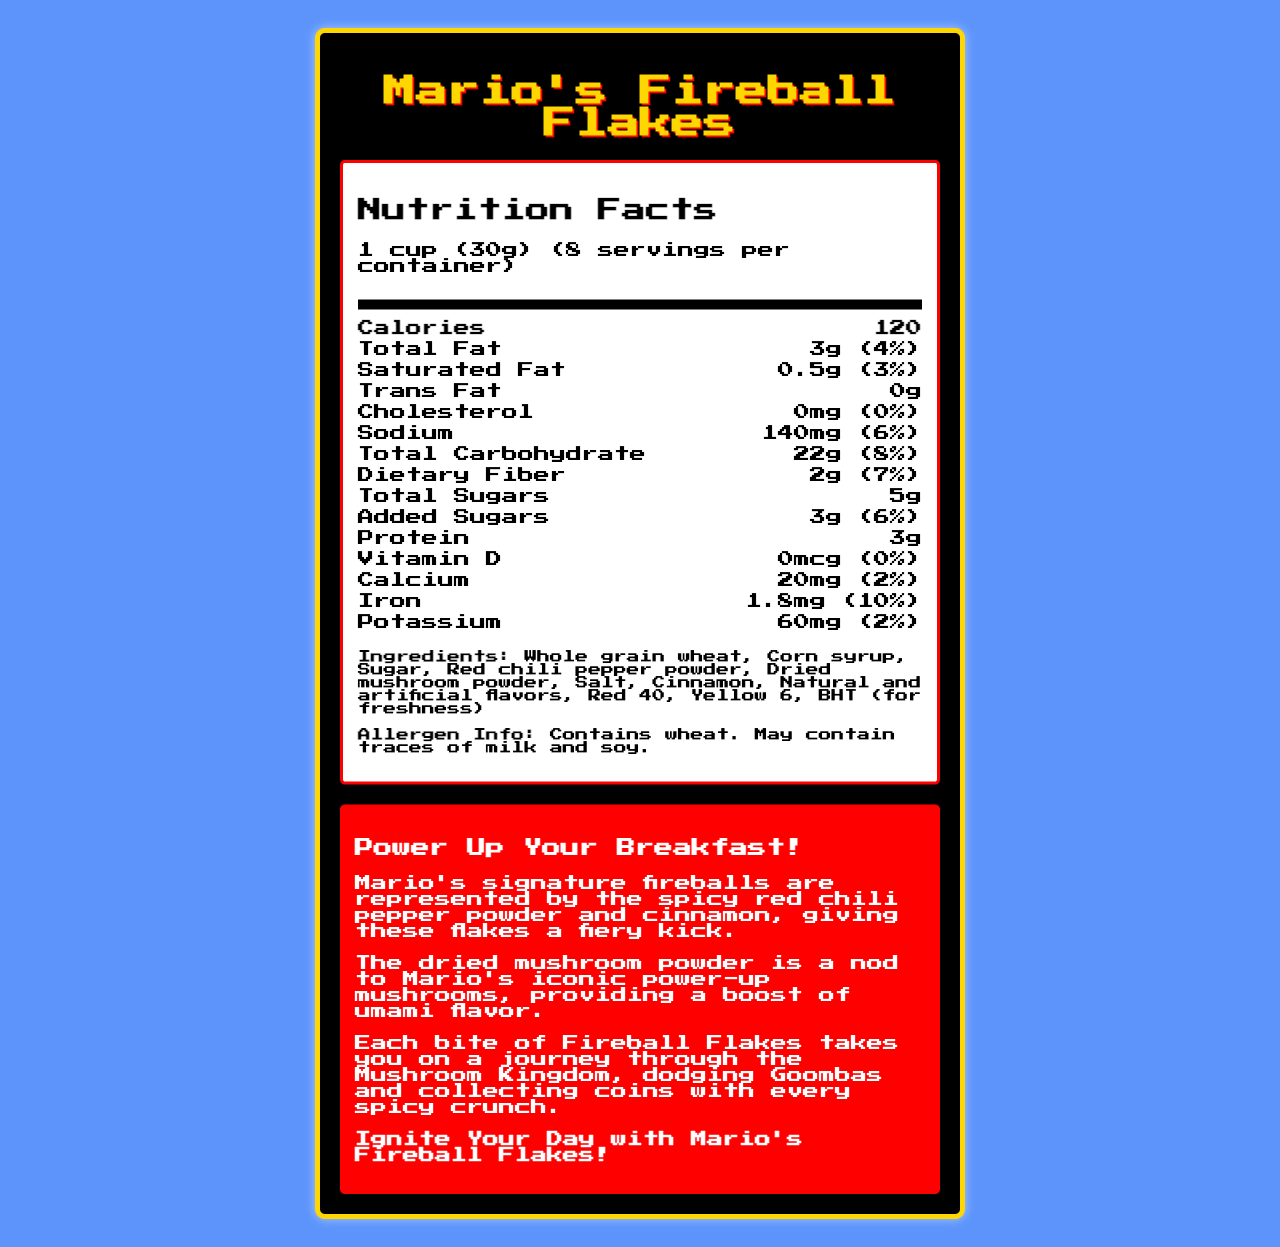what is the serving size for Mario's Fireball Flakes? The serving size is listed at the top of the Nutrition Facts section.
Answer: 1 cup (30g) How many calories are in one serving? The number of calories per serving is indicated in the Nutrition Facts section next to "Calories".
Answer: 120 What unique ingredient ties into Mario's fireball ability? The character tie-in narrative mentions red chili pepper powder representing Mario's fireballs.
Answer: Red chili pepper powder How many grams of protein are in one serving? The protein amount is listed in the Nutrition Facts section.
Answer: 3g What is the daily percentage value of potassium in one serving? The percent daily value for potassium is outlined in the Nutrition Facts section.
Answer: 2% What colors are used to match Mario's classic outfit in the cereal? A. Red and Blue B. Red and Yellow C. Yellow and Green D. Green and Blue The color scheme is mentioned as vibrant red and yellow to match Mario's classic outfit.
Answer: B. Red and Yellow Which power-up reference is related to the dried mushroom powder? 1. Fireballs 2. Super Star 3. Power-up mushrooms The dried mushroom powder is a nod to Mario's power-up mushrooms as per the narrative.
Answer: 3. Power-up mushrooms Does Mario's Fireball Flakes contain any traces of soy? The allergen info states that it may contain traces of milk and soy.
Answer: Yes What is the main idea of the document? The document provides a comprehensive overview of both the nutritional content and the thematic narrative related to the cereal.
Answer: The document is a Nutrition Facts label for a themed snack cereal called "Mario's Fireball Flakes," which integrates unique ingredients and narrative elements tied to Mario from popular video games. It includes detailed nutritional information, ingredients, allergen information, and narrative tie-ins. What is the sodium content in one serving? The sodium content is listed in the Nutrition Facts section next to "Sodium".
Answer: 140mg Does Mario's Fireball Flakes contain any trans fat? The Nutrition Facts section shows 0g of trans fat.
Answer: No What is the marketing tagline for Mario's Fireball Flakes? The marketing tagline is directly stated in the narrative section of the document.
Answer: Ignite Your Day with Mario's Fireball Flakes! Can you tell how much cholesterol is in one serving from the document? The Nutrition Facts section explicitly states the cholesterol content as 0mg.
Answer: 0mg What unique gameplay element can be found in 1 out of every 10 boxes? The gameplay mechanics mention that you can find Limited edition Super Star marshmallows in 1 out of every 10 boxes.
Answer: Limited edition Super Star marshmallows Does the document provide information about whether Super Stars grant permanent abilities? The document only mentions that Super Star marshmallows grant temporary invincibility to morning grogginess, without specifying permanent abilities.
Answer: No 